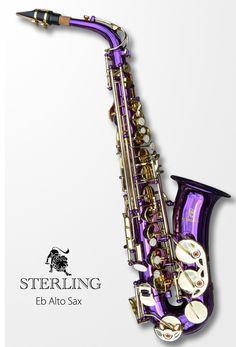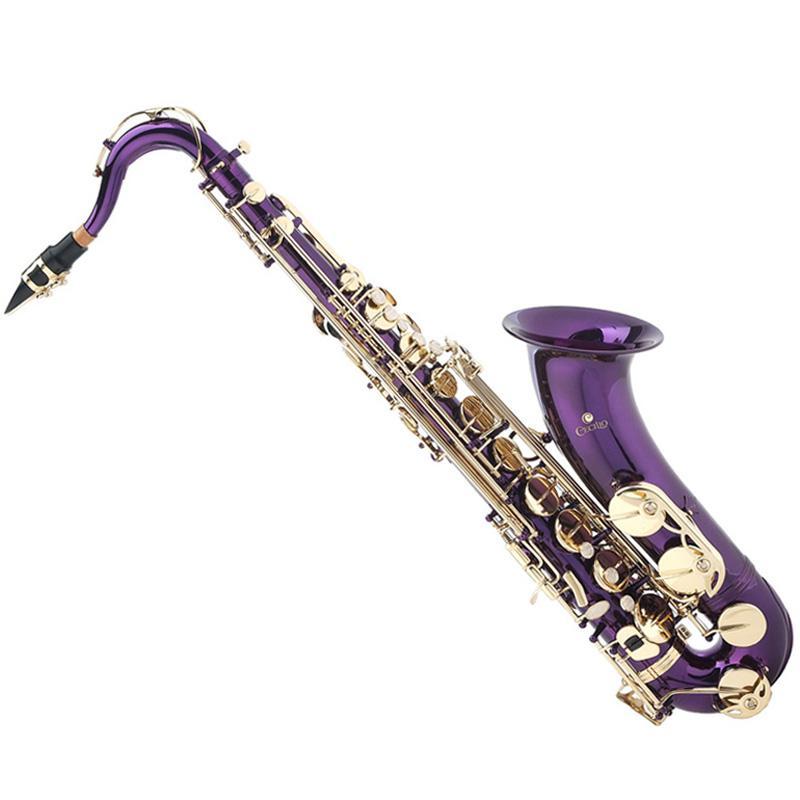The first image is the image on the left, the second image is the image on the right. Evaluate the accuracy of this statement regarding the images: "Both images contain a saxophone that is a blue or purple non-traditional color and all saxophones on the right have the bell facing upwards.". Is it true? Answer yes or no. Yes. The first image is the image on the left, the second image is the image on the right. Given the left and right images, does the statement "Both of the saxophone bodies share the same rich color, and it is not a traditional metallic (silver or gold) color." hold true? Answer yes or no. Yes. 